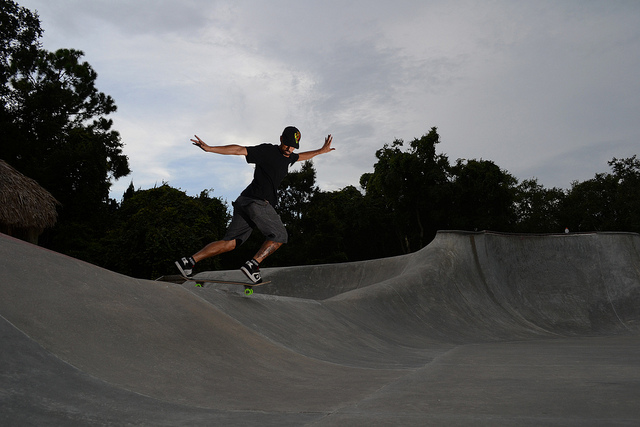<image>Is the skater good at the sport? I don't know if the skater is good at the sport. It can be both yes and no. Is the skater good at the sport? I don't know if the skater is good at the sport. It can be both yes and no. 